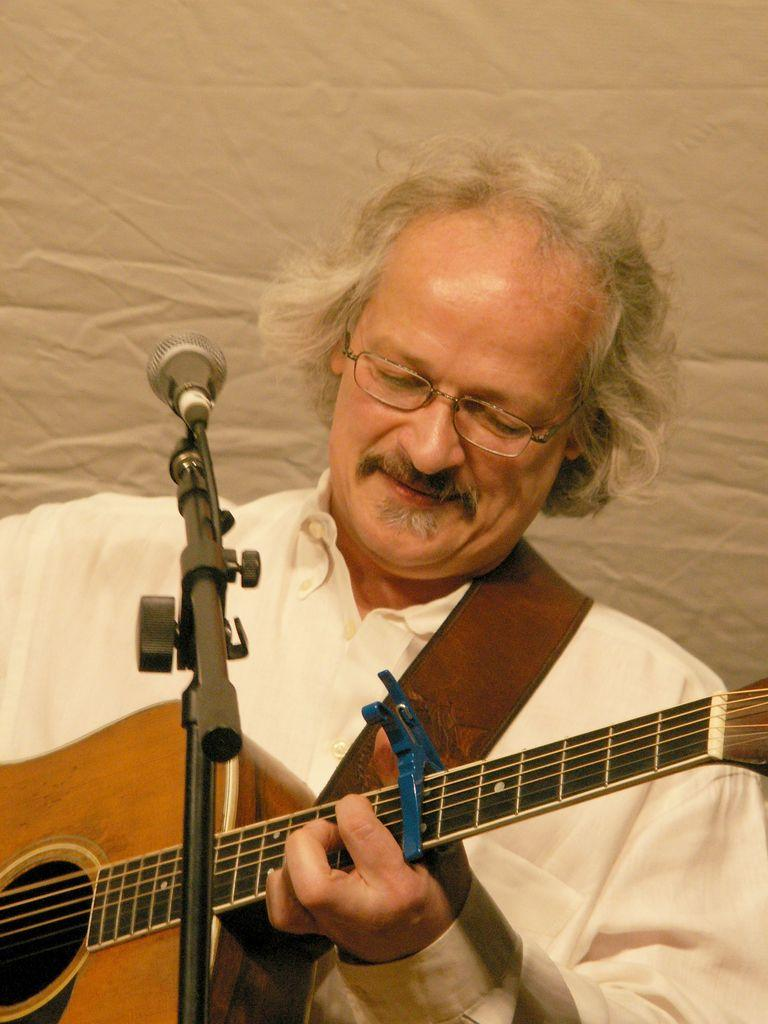What is the man in the image doing? The man is playing musical instruments in the image. What is the man using to amplify his voice? There is a microphone in the image, which the man might be using. What is the microphone attached to in the image? There is a microphone stand in the image, which the microphone is attached to. What color is the cloth in the background of the image? The white cloth is in the background of the image. What color is the man's shirt in the image? The man is wearing a white shirt in the image. How many beads are hanging from the man's veil in the image? There is no veil or beads present in the image. What type of ducks can be seen swimming in the background of the image? There are no ducks present in the image; the background features a white cloth. 